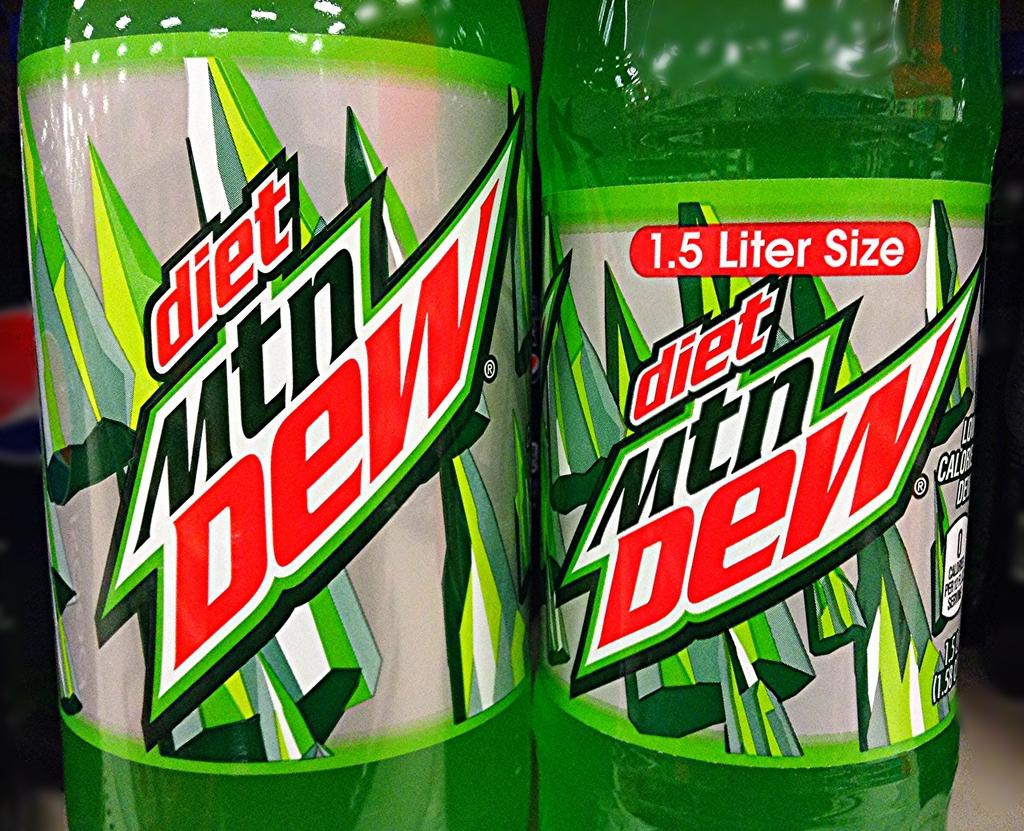<image>
Summarize the visual content of the image. Closeup photos of 2 bottles of diet mountain dew, one of which is 1.5 liters. 